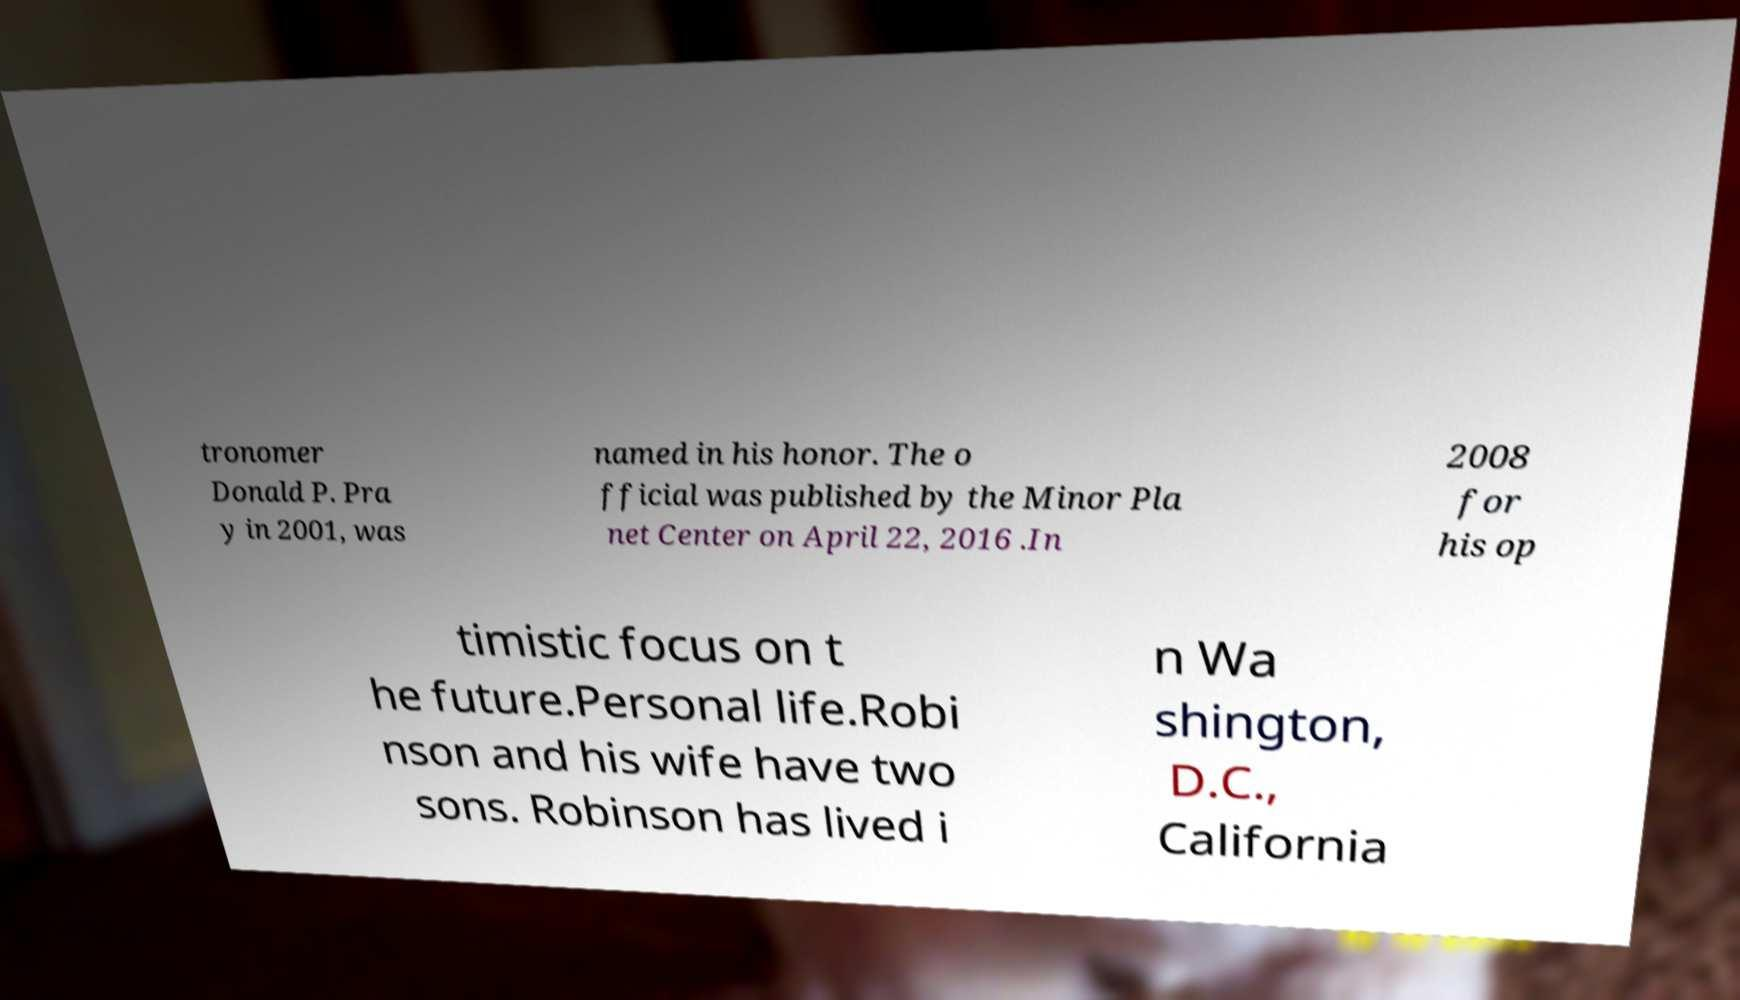Could you extract and type out the text from this image? tronomer Donald P. Pra y in 2001, was named in his honor. The o fficial was published by the Minor Pla net Center on April 22, 2016 .In 2008 for his op timistic focus on t he future.Personal life.Robi nson and his wife have two sons. Robinson has lived i n Wa shington, D.C., California 